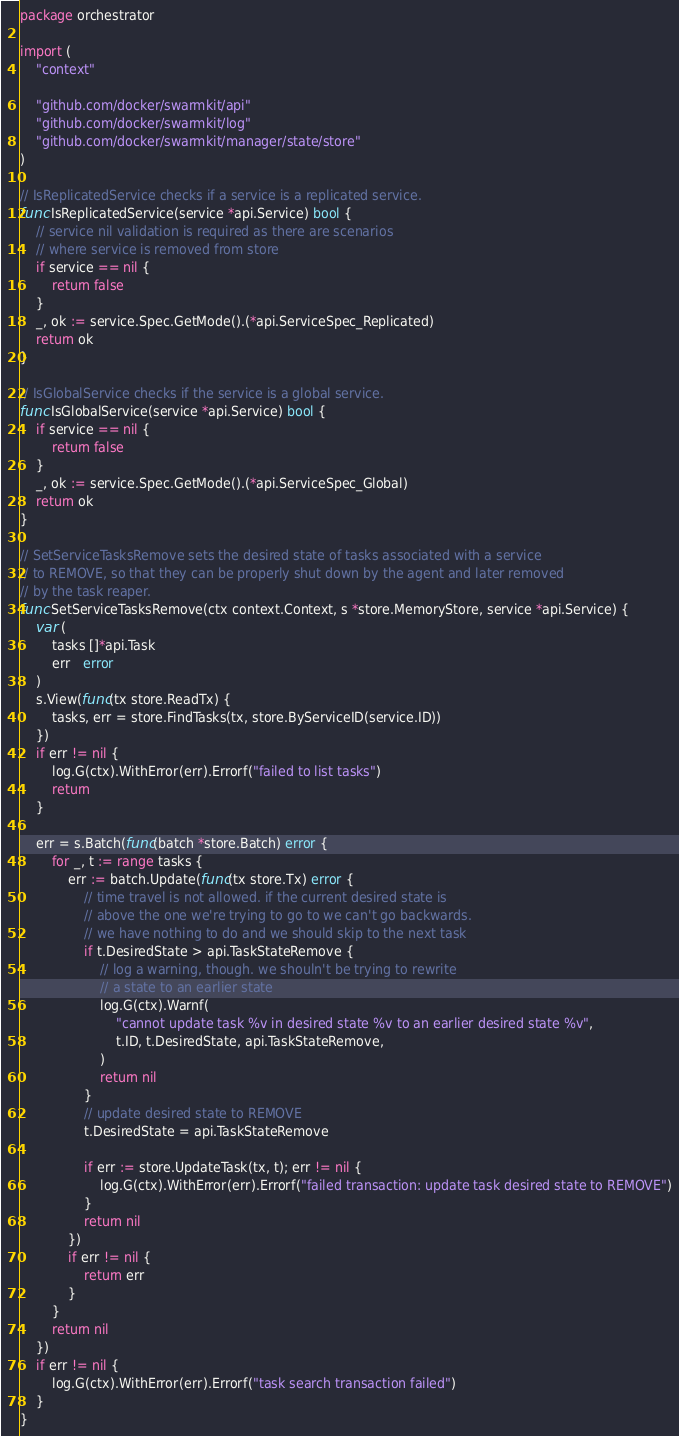Convert code to text. <code><loc_0><loc_0><loc_500><loc_500><_Go_>package orchestrator

import (
	"context"

	"github.com/docker/swarmkit/api"
	"github.com/docker/swarmkit/log"
	"github.com/docker/swarmkit/manager/state/store"
)

// IsReplicatedService checks if a service is a replicated service.
func IsReplicatedService(service *api.Service) bool {
	// service nil validation is required as there are scenarios
	// where service is removed from store
	if service == nil {
		return false
	}
	_, ok := service.Spec.GetMode().(*api.ServiceSpec_Replicated)
	return ok
}

// IsGlobalService checks if the service is a global service.
func IsGlobalService(service *api.Service) bool {
	if service == nil {
		return false
	}
	_, ok := service.Spec.GetMode().(*api.ServiceSpec_Global)
	return ok
}

// SetServiceTasksRemove sets the desired state of tasks associated with a service
// to REMOVE, so that they can be properly shut down by the agent and later removed
// by the task reaper.
func SetServiceTasksRemove(ctx context.Context, s *store.MemoryStore, service *api.Service) {
	var (
		tasks []*api.Task
		err   error
	)
	s.View(func(tx store.ReadTx) {
		tasks, err = store.FindTasks(tx, store.ByServiceID(service.ID))
	})
	if err != nil {
		log.G(ctx).WithError(err).Errorf("failed to list tasks")
		return
	}

	err = s.Batch(func(batch *store.Batch) error {
		for _, t := range tasks {
			err := batch.Update(func(tx store.Tx) error {
				// time travel is not allowed. if the current desired state is
				// above the one we're trying to go to we can't go backwards.
				// we have nothing to do and we should skip to the next task
				if t.DesiredState > api.TaskStateRemove {
					// log a warning, though. we shouln't be trying to rewrite
					// a state to an earlier state
					log.G(ctx).Warnf(
						"cannot update task %v in desired state %v to an earlier desired state %v",
						t.ID, t.DesiredState, api.TaskStateRemove,
					)
					return nil
				}
				// update desired state to REMOVE
				t.DesiredState = api.TaskStateRemove

				if err := store.UpdateTask(tx, t); err != nil {
					log.G(ctx).WithError(err).Errorf("failed transaction: update task desired state to REMOVE")
				}
				return nil
			})
			if err != nil {
				return err
			}
		}
		return nil
	})
	if err != nil {
		log.G(ctx).WithError(err).Errorf("task search transaction failed")
	}
}
</code> 